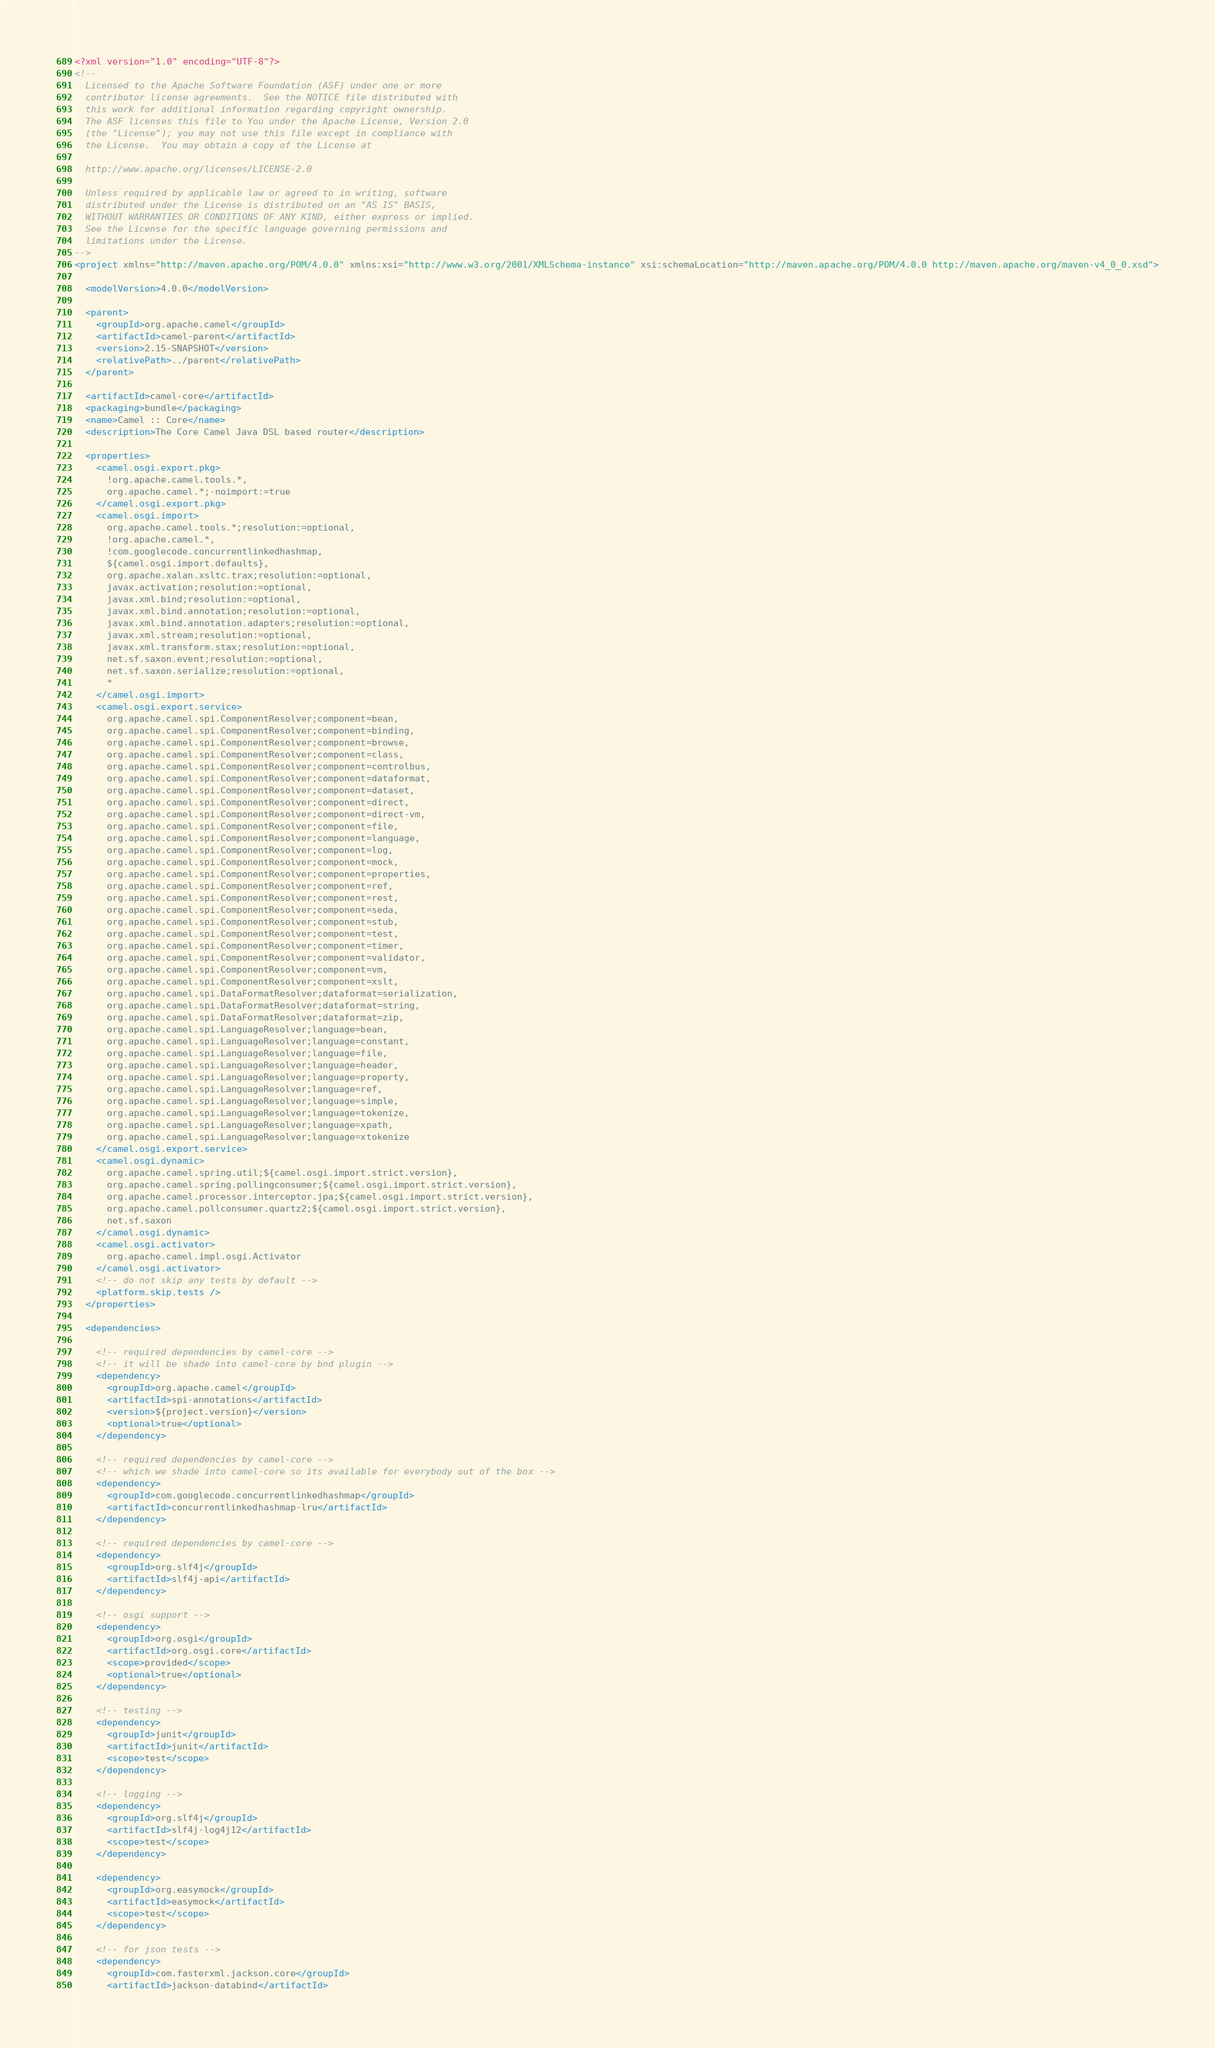<code> <loc_0><loc_0><loc_500><loc_500><_XML_><?xml version="1.0" encoding="UTF-8"?>
<!--
  Licensed to the Apache Software Foundation (ASF) under one or more
  contributor license agreements.  See the NOTICE file distributed with
  this work for additional information regarding copyright ownership.
  The ASF licenses this file to You under the Apache License, Version 2.0
  (the "License"); you may not use this file except in compliance with
  the License.  You may obtain a copy of the License at

  http://www.apache.org/licenses/LICENSE-2.0

  Unless required by applicable law or agreed to in writing, software
  distributed under the License is distributed on an "AS IS" BASIS,
  WITHOUT WARRANTIES OR CONDITIONS OF ANY KIND, either express or implied.
  See the License for the specific language governing permissions and
  limitations under the License.
-->
<project xmlns="http://maven.apache.org/POM/4.0.0" xmlns:xsi="http://www.w3.org/2001/XMLSchema-instance" xsi:schemaLocation="http://maven.apache.org/POM/4.0.0 http://maven.apache.org/maven-v4_0_0.xsd">

  <modelVersion>4.0.0</modelVersion>

  <parent>
    <groupId>org.apache.camel</groupId>
    <artifactId>camel-parent</artifactId>
    <version>2.15-SNAPSHOT</version>
    <relativePath>../parent</relativePath>
  </parent>

  <artifactId>camel-core</artifactId>
  <packaging>bundle</packaging>
  <name>Camel :: Core</name>
  <description>The Core Camel Java DSL based router</description>

  <properties>
    <camel.osgi.export.pkg>
      !org.apache.camel.tools.*,
      org.apache.camel.*;-noimport:=true
    </camel.osgi.export.pkg>
    <camel.osgi.import>
      org.apache.camel.tools.*;resolution:=optional,
      !org.apache.camel.*,
      !com.googlecode.concurrentlinkedhashmap,
      ${camel.osgi.import.defaults},
      org.apache.xalan.xsltc.trax;resolution:=optional,
      javax.activation;resolution:=optional,
      javax.xml.bind;resolution:=optional,
      javax.xml.bind.annotation;resolution:=optional,
      javax.xml.bind.annotation.adapters;resolution:=optional,
      javax.xml.stream;resolution:=optional,
      javax.xml.transform.stax;resolution:=optional,
      net.sf.saxon.event;resolution:=optional,
      net.sf.saxon.serialize;resolution:=optional,
      *
    </camel.osgi.import>
    <camel.osgi.export.service>
      org.apache.camel.spi.ComponentResolver;component=bean,
      org.apache.camel.spi.ComponentResolver;component=binding,
      org.apache.camel.spi.ComponentResolver;component=browse,
      org.apache.camel.spi.ComponentResolver;component=class,
      org.apache.camel.spi.ComponentResolver;component=controlbus,
      org.apache.camel.spi.ComponentResolver;component=dataformat,
      org.apache.camel.spi.ComponentResolver;component=dataset,
      org.apache.camel.spi.ComponentResolver;component=direct,
      org.apache.camel.spi.ComponentResolver;component=direct-vm,
      org.apache.camel.spi.ComponentResolver;component=file,
      org.apache.camel.spi.ComponentResolver;component=language,
      org.apache.camel.spi.ComponentResolver;component=log,
      org.apache.camel.spi.ComponentResolver;component=mock,
      org.apache.camel.spi.ComponentResolver;component=properties,
      org.apache.camel.spi.ComponentResolver;component=ref,
      org.apache.camel.spi.ComponentResolver;component=rest,
      org.apache.camel.spi.ComponentResolver;component=seda,
      org.apache.camel.spi.ComponentResolver;component=stub,
      org.apache.camel.spi.ComponentResolver;component=test,
      org.apache.camel.spi.ComponentResolver;component=timer,
      org.apache.camel.spi.ComponentResolver;component=validator,
      org.apache.camel.spi.ComponentResolver;component=vm,
      org.apache.camel.spi.ComponentResolver;component=xslt,
      org.apache.camel.spi.DataFormatResolver;dataformat=serialization,
      org.apache.camel.spi.DataFormatResolver;dataformat=string,
      org.apache.camel.spi.DataFormatResolver;dataformat=zip,
      org.apache.camel.spi.LanguageResolver;language=bean,
      org.apache.camel.spi.LanguageResolver;language=constant,
      org.apache.camel.spi.LanguageResolver;language=file,
      org.apache.camel.spi.LanguageResolver;language=header,
      org.apache.camel.spi.LanguageResolver;language=property,
      org.apache.camel.spi.LanguageResolver;language=ref,
      org.apache.camel.spi.LanguageResolver;language=simple,
      org.apache.camel.spi.LanguageResolver;language=tokenize,
      org.apache.camel.spi.LanguageResolver;language=xpath,
      org.apache.camel.spi.LanguageResolver;language=xtokenize
    </camel.osgi.export.service>
    <camel.osgi.dynamic>
      org.apache.camel.spring.util;${camel.osgi.import.strict.version},
      org.apache.camel.spring.pollingconsumer;${camel.osgi.import.strict.version},
      org.apache.camel.processor.interceptor.jpa;${camel.osgi.import.strict.version},
      org.apache.camel.pollconsumer.quartz2;${camel.osgi.import.strict.version},
      net.sf.saxon
    </camel.osgi.dynamic>
    <camel.osgi.activator>
      org.apache.camel.impl.osgi.Activator
    </camel.osgi.activator>
    <!-- do not skip any tests by default -->
    <platform.skip.tests />
  </properties>

  <dependencies>

    <!-- required dependencies by camel-core -->
    <!-- it will be shade into camel-core by bnd plugin -->
    <dependency>
      <groupId>org.apache.camel</groupId>
      <artifactId>spi-annotations</artifactId>
      <version>${project.version}</version>
      <optional>true</optional>
    </dependency>

    <!-- required dependencies by camel-core -->
    <!-- which we shade into camel-core so its available for everybody out of the box -->
    <dependency>
      <groupId>com.googlecode.concurrentlinkedhashmap</groupId>
      <artifactId>concurrentlinkedhashmap-lru</artifactId>
    </dependency>

    <!-- required dependencies by camel-core -->
    <dependency>
      <groupId>org.slf4j</groupId>
      <artifactId>slf4j-api</artifactId>
    </dependency>

    <!-- osgi support -->
    <dependency>
      <groupId>org.osgi</groupId>
      <artifactId>org.osgi.core</artifactId>
      <scope>provided</scope>
      <optional>true</optional>
    </dependency>

    <!-- testing -->
    <dependency>
      <groupId>junit</groupId>
      <artifactId>junit</artifactId>
      <scope>test</scope>
    </dependency>

    <!-- logging -->
    <dependency>
      <groupId>org.slf4j</groupId>
      <artifactId>slf4j-log4j12</artifactId>
      <scope>test</scope>
    </dependency>

    <dependency>
      <groupId>org.easymock</groupId>
      <artifactId>easymock</artifactId>
      <scope>test</scope>
    </dependency>

    <!-- for json tests -->
    <dependency>
      <groupId>com.fasterxml.jackson.core</groupId>
      <artifactId>jackson-databind</artifactId></code> 